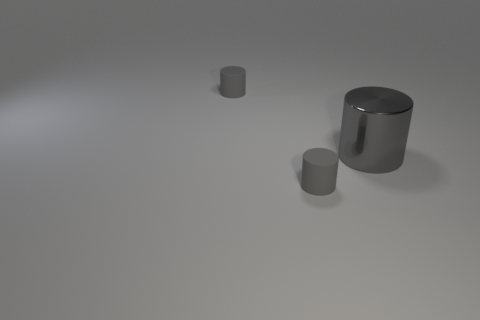Subtract all gray cylinders. How many were subtracted if there are1gray cylinders left? 2 Subtract 1 cylinders. How many cylinders are left? 2 Add 2 tiny green shiny blocks. How many objects exist? 5 Subtract all rubber cylinders. How many cylinders are left? 1 Subtract all green cylinders. Subtract all yellow spheres. How many cylinders are left? 3 Add 1 large gray shiny objects. How many large gray shiny objects are left? 2 Add 1 gray shiny things. How many gray shiny things exist? 2 Subtract 0 gray spheres. How many objects are left? 3 Subtract all matte cylinders. Subtract all large gray shiny objects. How many objects are left? 0 